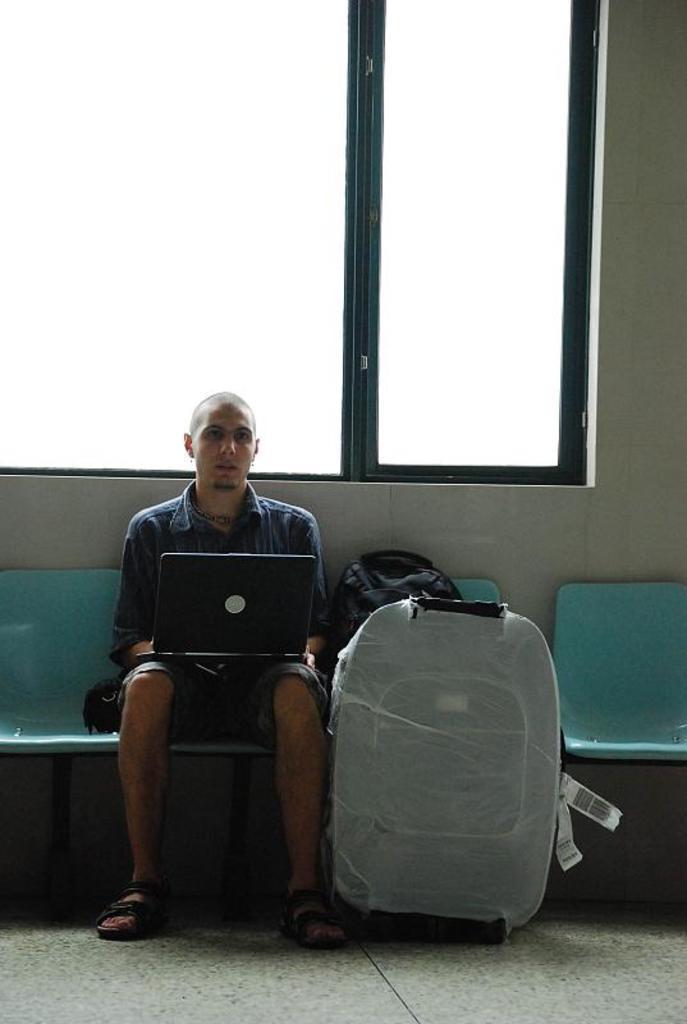Could you give a brief overview of what you see in this image? This person sitting on a chair. This person carries a laptop. Beside this person there is a bag and luggage. This is window with door. 